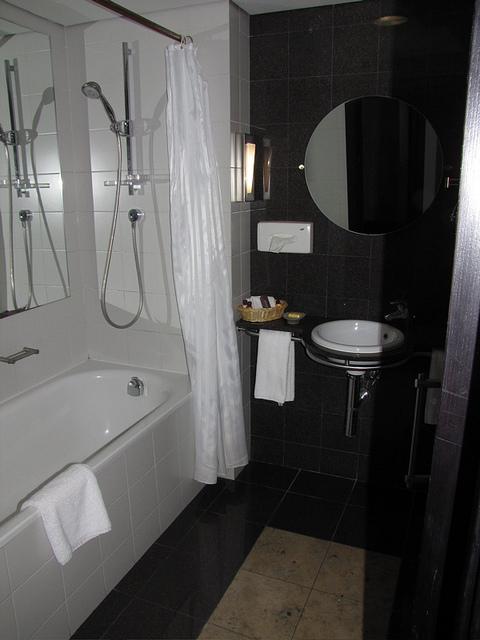Where is this?
Give a very brief answer. Bathroom. How many trains are there?
Short answer required. 0. How many mirrors are in the bathroom?
Write a very short answer. 2. How many faucets does the sink have?
Short answer required. 1. What color is the sink?
Concise answer only. White. Is this an old fashioned bathroom?
Keep it brief. No. 